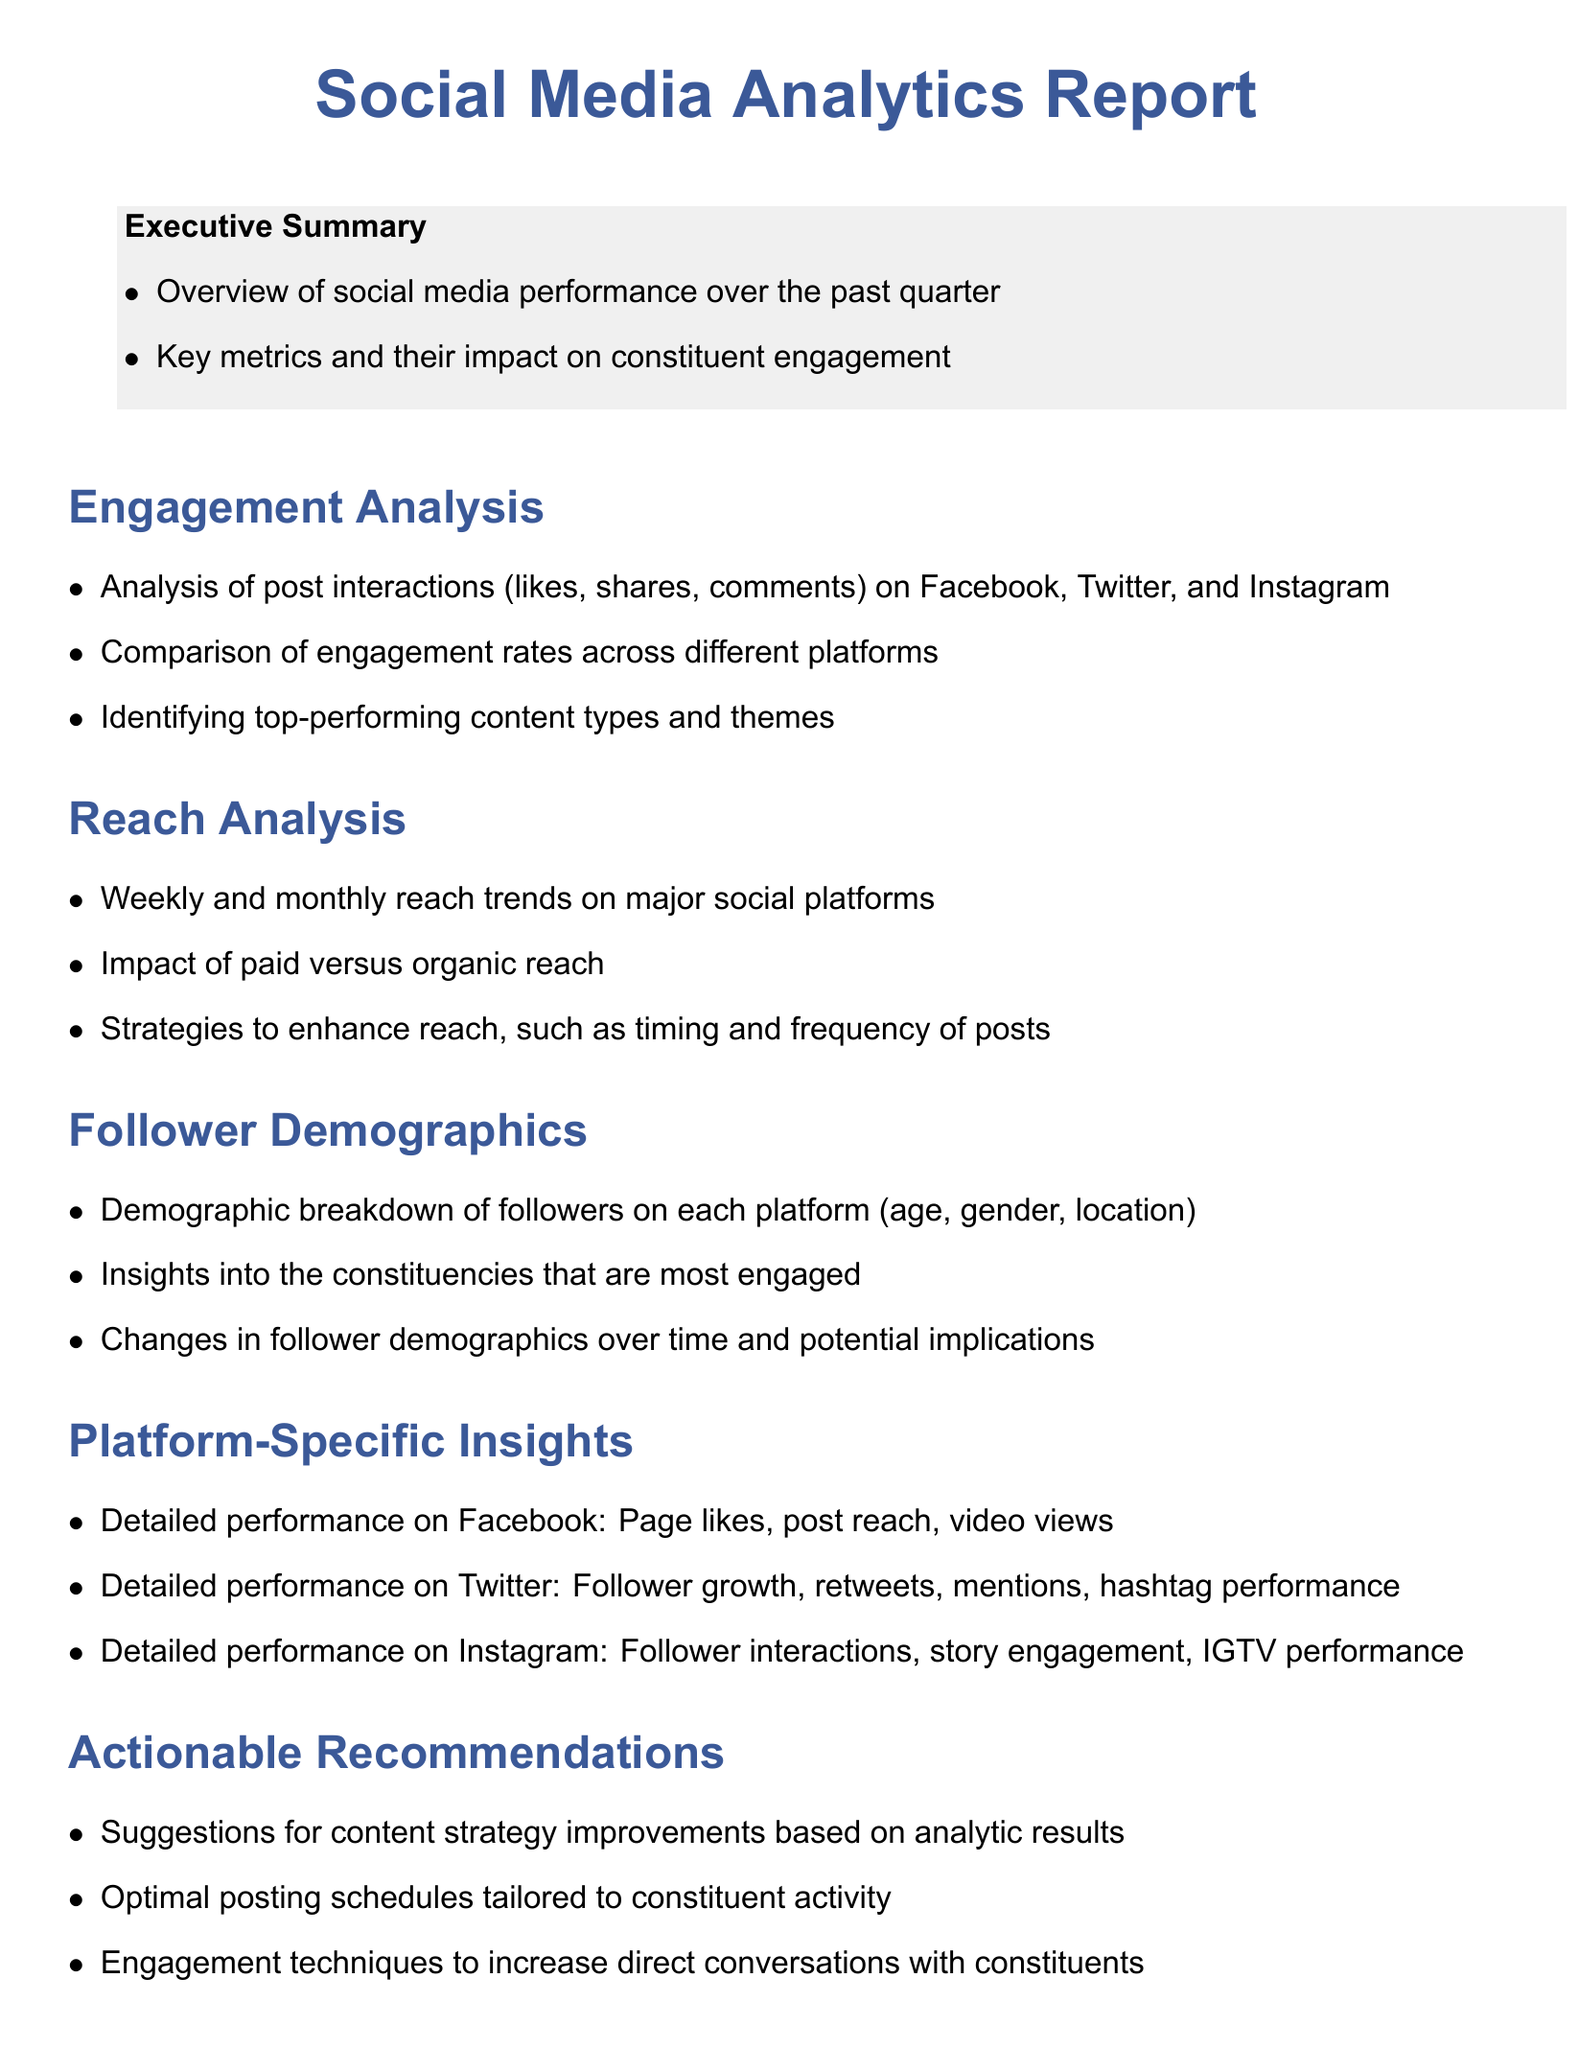What is the focus of the Executive Summary? The Executive Summary provides an overview of social media performance and key metrics impacting engagement.
Answer: Overview of social media performance over the past quarter, key metrics and their impact on constituent engagement What are the key platforms analyzed for engagement? The document specifies three platforms where post interactions are analyzed.
Answer: Facebook, Twitter, and Instagram What is one of the engagement techniques suggested? The report outlines various strategies to increase communication with constituents; one such technique involves encouraging direct conversations.
Answer: Engagement techniques to increase direct conversations with constituents What demographic aspects are analyzed for followers? The document categorizes followers' demographics into specific characteristics to gain insights into engagement.
Answer: Age, gender, location What does the report recommend for posting schedules? The actionable recommendations section suggests optimizing timings based on certain best practices.
Answer: Optimal posting schedules tailored to constituent activity What is the purpose of the Appendix? The Appendix contains supplementary information that supports the findings of the main report.
Answer: Glossary of key metrics and terms, methodology for data collection and analysis, additional charts and graphs supporting the findings 